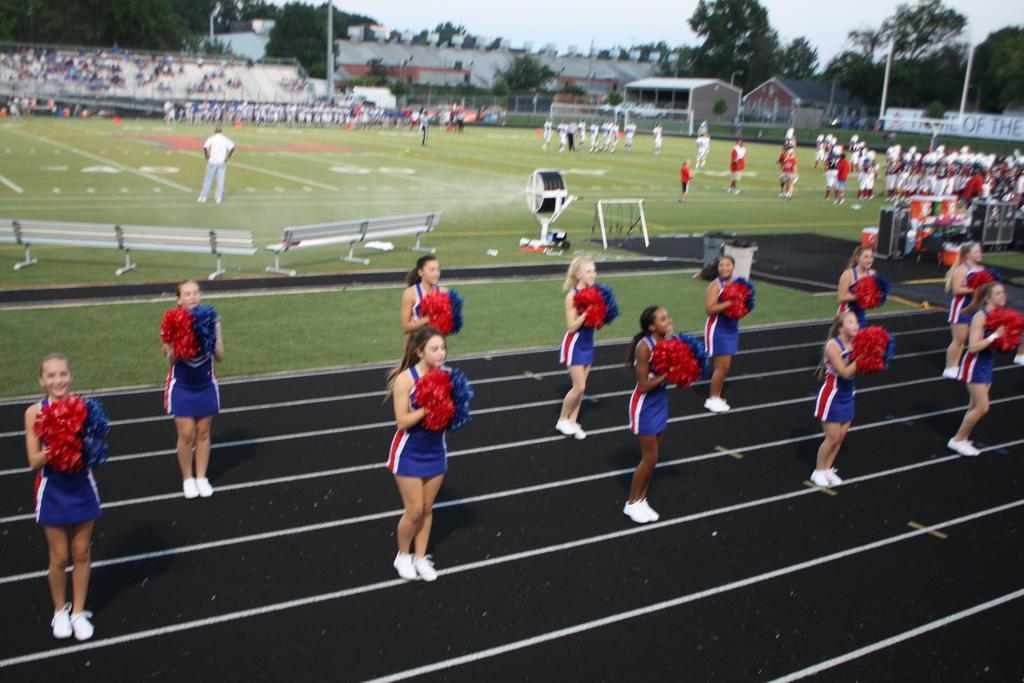What is the primary location of the people in the image? The people are on the ground in the image. What type of seating is available in the image? There are benches and at least one chair in the image. What is the mesh used for in the image? The purpose of the mesh in the image is not specified, but it could be used for various purposes such as fencing or decoration. What type of audio equipment is present in the image? There are speakers in the image. What type of vertical structures are present in the image? There are poles in the image. What type of vegetation is present in the image? There are trees in the image. What type of small structures are present in the image? There are sheds in the image. What can be seen in the background of the image? The sky is visible in the background of the image. How many parcels are being coughed by the people in the image? There are no parcels or coughing people present in the image. What type of downtown area is depicted in the image? The image does not depict a downtown area; it contains people, benches, chairs, mesh, speakers, poles, trees, sheds, and a visible sky. 